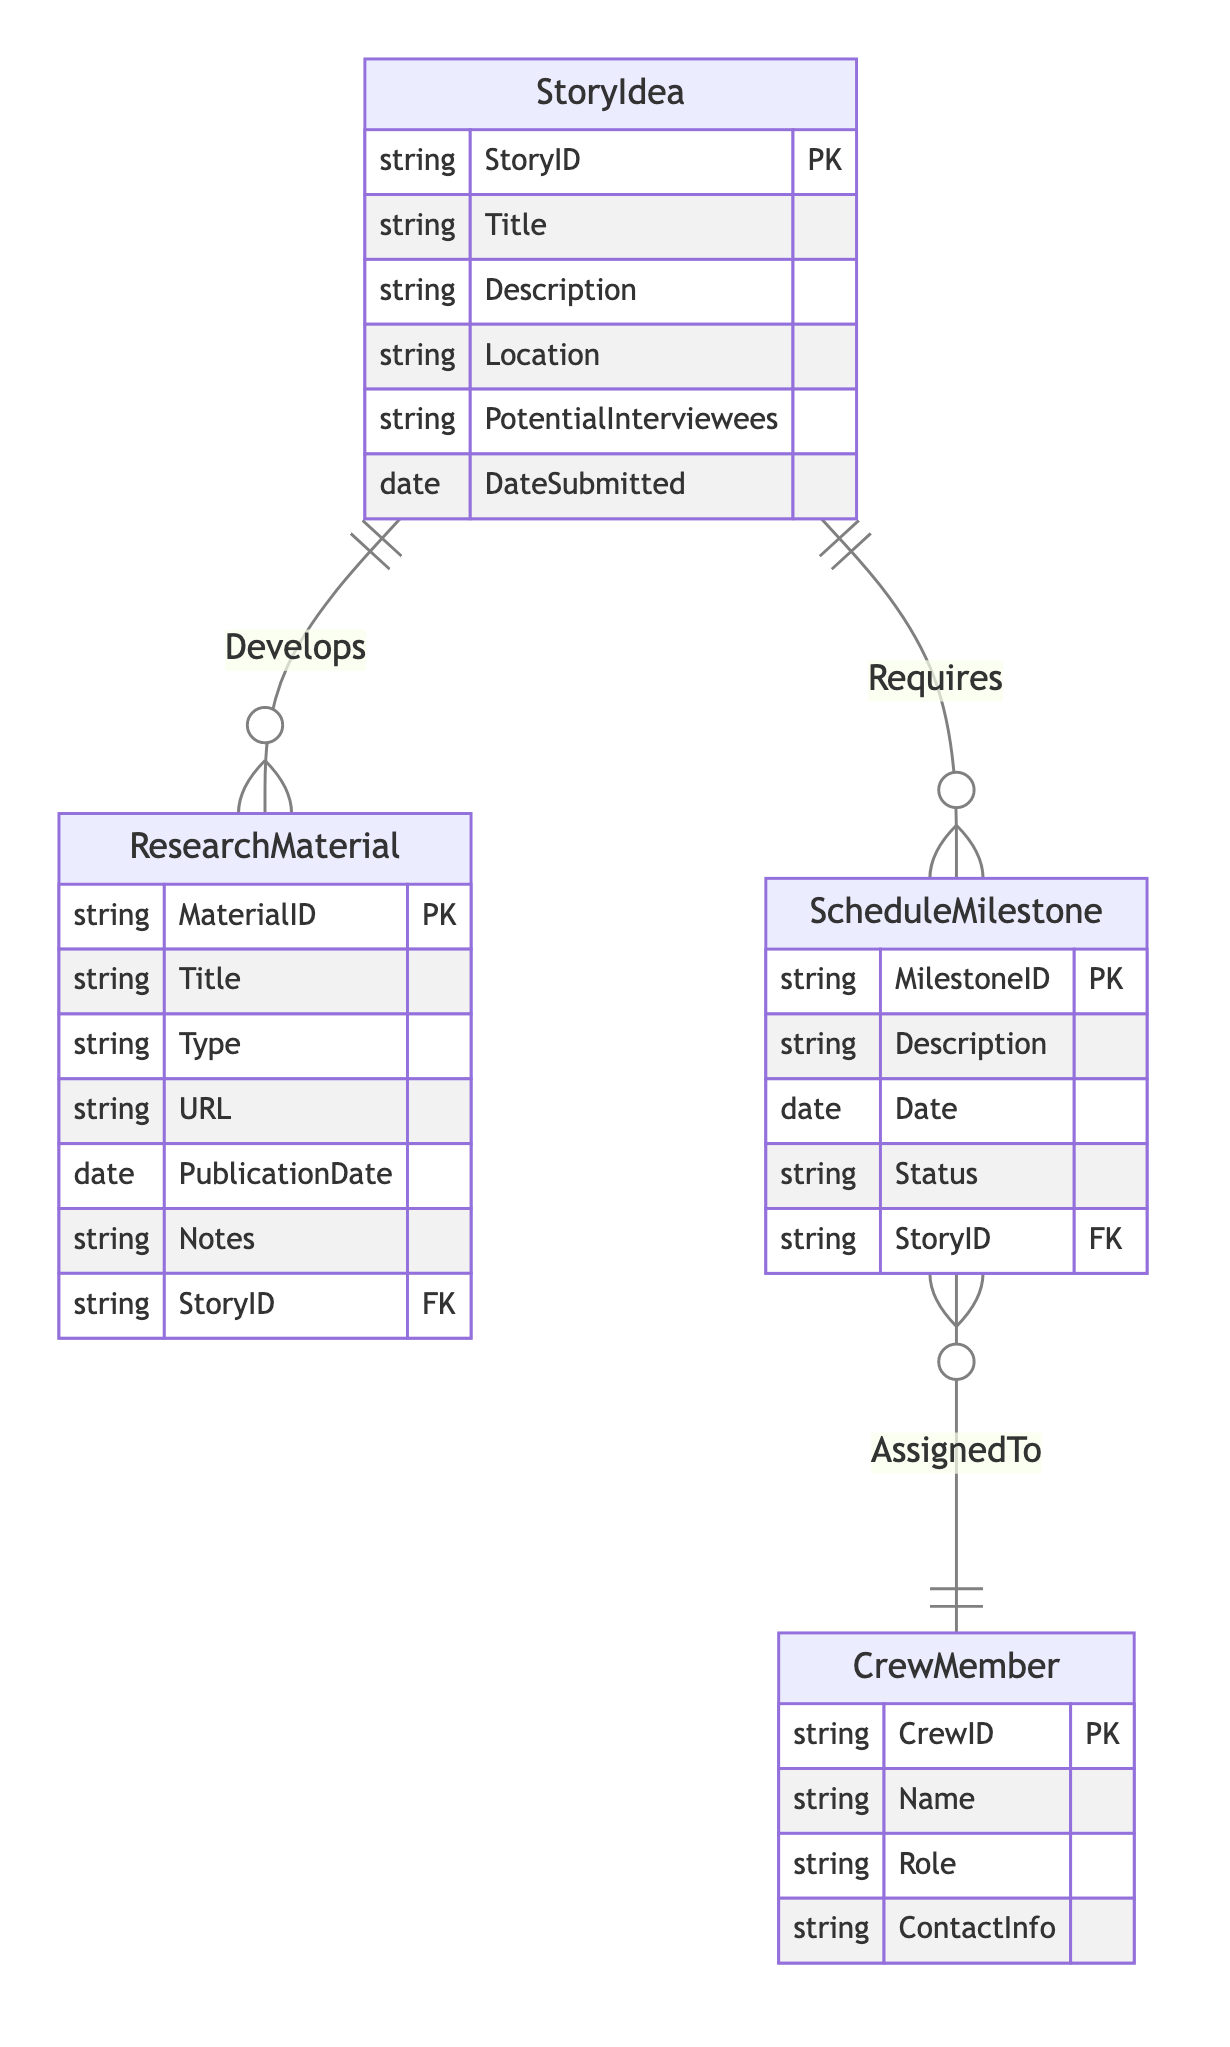What are the main entities in the diagram? The diagram contains four main entities: StoryIdea, ResearchMaterial, ScheduleMilestone, and CrewMember.
Answer: StoryIdea, ResearchMaterial, ScheduleMilestone, CrewMember What relationship connects StoryIdea and ResearchMaterial? The relationship that connects StoryIdea and ResearchMaterial is named "Develops." This indicates that a StoryIdea can lead to the creation of multiple ResearchMaterials.
Answer: Develops How many relationships are present in the diagram? There are three relationships in the diagram: Develops, Requires, and AssignedTo. Each of these connections links different entities, highlighting their interactions.
Answer: Three Which entity has the attribute "MilestoneID"? The attribute "MilestoneID" is part of the ScheduleMilestone entity, which uniquely identifies each milestone related to the episode planning process.
Answer: ScheduleMilestone What is the primary key of the CrewMember entity? The primary key of the CrewMember entity is "CrewID," which serves as the unique identifier for each crew member in the database.
Answer: CrewID How many attributes does the StoryIdea entity have? The StoryIdea entity has six attributes: StoryID, Title, Description, Location, PotentialInterviewees, and DateSubmitted. This allows for comprehensive information on each story idea.
Answer: Six Which entity is dependent on the StoryID attribute? Both the ResearchMaterial and ScheduleMilestone entities depend on the StoryID attribute as they have it as a foreign key, linking them back to the corresponding story idea.
Answer: ResearchMaterial, ScheduleMilestone What does the "AssignedTo" relationship represent? The "AssignedTo" relationship represents the connection between ScheduleMilestone and CrewMember, indicating which crew member is responsible for a given milestone in the planning process.
Answer: Connection between ScheduleMilestone and CrewMember Which entity allows documenting research sources? The ResearchMaterial entity allows documenting research sources related to each story idea, including details such as title, type, and URLs for access.
Answer: ResearchMaterial 